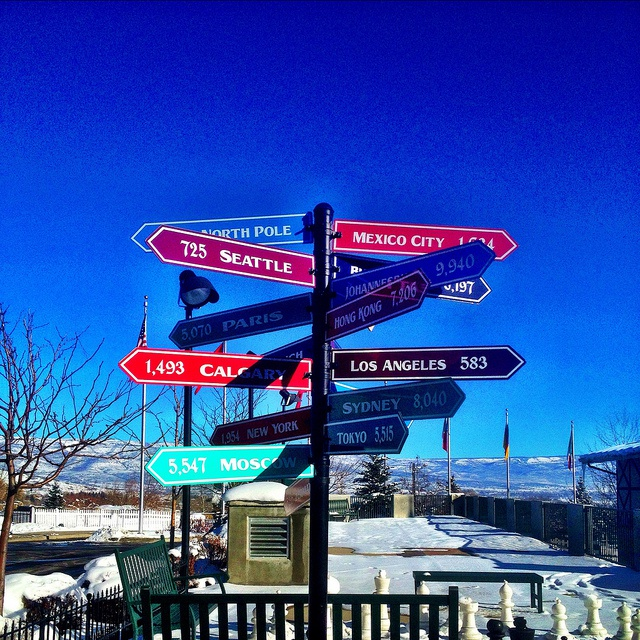Describe the objects in this image and their specific colors. I can see bench in navy, black, teal, gray, and lightgray tones, bench in navy, black, gray, and darkgray tones, and bench in navy, teal, black, and darkgray tones in this image. 